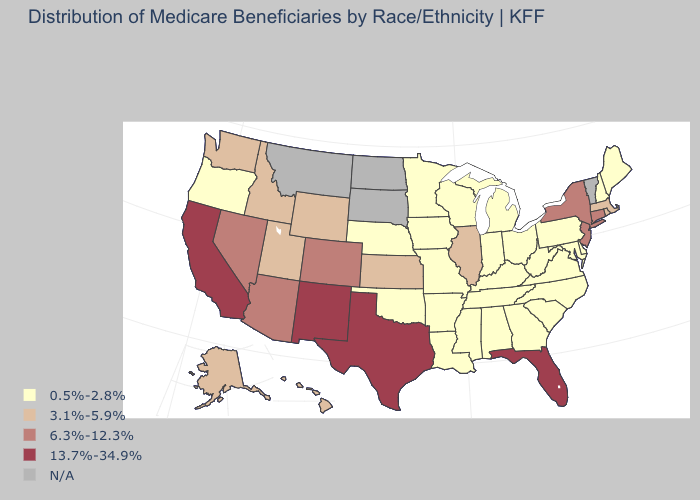Which states have the lowest value in the West?
Write a very short answer. Oregon. Which states have the highest value in the USA?
Be succinct. California, Florida, New Mexico, Texas. What is the lowest value in the USA?
Quick response, please. 0.5%-2.8%. Among the states that border Nebraska , which have the highest value?
Answer briefly. Colorado. What is the value of Montana?
Be succinct. N/A. What is the value of New York?
Keep it brief. 6.3%-12.3%. Which states have the lowest value in the USA?
Give a very brief answer. Alabama, Arkansas, Delaware, Georgia, Indiana, Iowa, Kentucky, Louisiana, Maine, Maryland, Michigan, Minnesota, Mississippi, Missouri, Nebraska, New Hampshire, North Carolina, Ohio, Oklahoma, Oregon, Pennsylvania, South Carolina, Tennessee, Virginia, West Virginia, Wisconsin. Name the states that have a value in the range 3.1%-5.9%?
Give a very brief answer. Alaska, Hawaii, Idaho, Illinois, Kansas, Massachusetts, Rhode Island, Utah, Washington, Wyoming. Name the states that have a value in the range 13.7%-34.9%?
Answer briefly. California, Florida, New Mexico, Texas. What is the value of New Hampshire?
Be succinct. 0.5%-2.8%. Among the states that border Delaware , does New Jersey have the highest value?
Keep it brief. Yes. Name the states that have a value in the range 3.1%-5.9%?
Give a very brief answer. Alaska, Hawaii, Idaho, Illinois, Kansas, Massachusetts, Rhode Island, Utah, Washington, Wyoming. What is the value of Oregon?
Keep it brief. 0.5%-2.8%. 